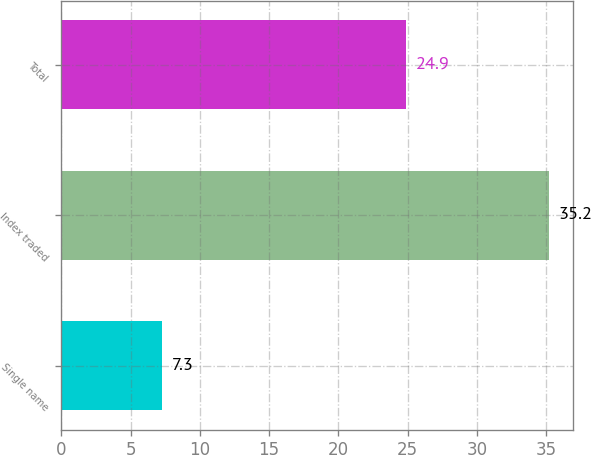<chart> <loc_0><loc_0><loc_500><loc_500><bar_chart><fcel>Single name<fcel>Index traded<fcel>Total<nl><fcel>7.3<fcel>35.2<fcel>24.9<nl></chart> 